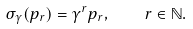Convert formula to latex. <formula><loc_0><loc_0><loc_500><loc_500>\sigma _ { \gamma } ( p _ { r } ) = \gamma ^ { r } p _ { r } , \quad r \in \mathbb { N } .</formula> 